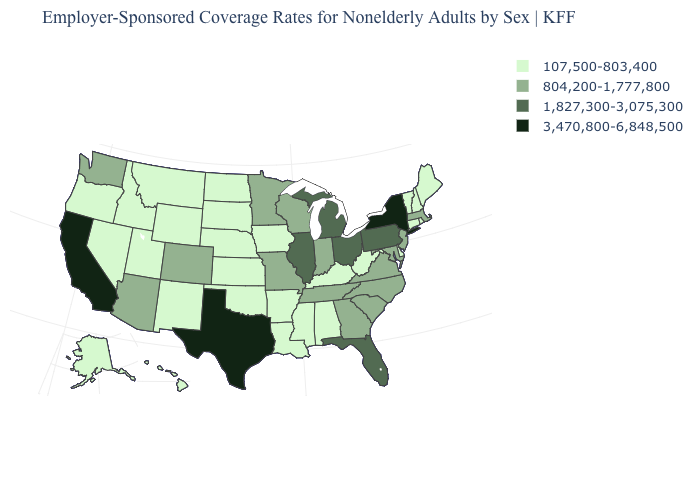Name the states that have a value in the range 804,200-1,777,800?
Keep it brief. Arizona, Colorado, Georgia, Indiana, Maryland, Massachusetts, Minnesota, Missouri, New Jersey, North Carolina, South Carolina, Tennessee, Virginia, Washington, Wisconsin. What is the value of Utah?
Keep it brief. 107,500-803,400. Name the states that have a value in the range 804,200-1,777,800?
Write a very short answer. Arizona, Colorado, Georgia, Indiana, Maryland, Massachusetts, Minnesota, Missouri, New Jersey, North Carolina, South Carolina, Tennessee, Virginia, Washington, Wisconsin. What is the highest value in the USA?
Answer briefly. 3,470,800-6,848,500. Does the first symbol in the legend represent the smallest category?
Give a very brief answer. Yes. What is the value of South Carolina?
Keep it brief. 804,200-1,777,800. Does Idaho have a lower value than Minnesota?
Quick response, please. Yes. Name the states that have a value in the range 107,500-803,400?
Write a very short answer. Alabama, Alaska, Arkansas, Connecticut, Delaware, Hawaii, Idaho, Iowa, Kansas, Kentucky, Louisiana, Maine, Mississippi, Montana, Nebraska, Nevada, New Hampshire, New Mexico, North Dakota, Oklahoma, Oregon, Rhode Island, South Dakota, Utah, Vermont, West Virginia, Wyoming. Name the states that have a value in the range 1,827,300-3,075,300?
Concise answer only. Florida, Illinois, Michigan, Ohio, Pennsylvania. Name the states that have a value in the range 3,470,800-6,848,500?
Give a very brief answer. California, New York, Texas. What is the value of Ohio?
Quick response, please. 1,827,300-3,075,300. What is the value of Alabama?
Be succinct. 107,500-803,400. Does New Mexico have the same value as New York?
Answer briefly. No. What is the highest value in states that border Idaho?
Concise answer only. 804,200-1,777,800. What is the highest value in the USA?
Be succinct. 3,470,800-6,848,500. 